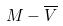<formula> <loc_0><loc_0><loc_500><loc_500>M - \overline { V }</formula> 